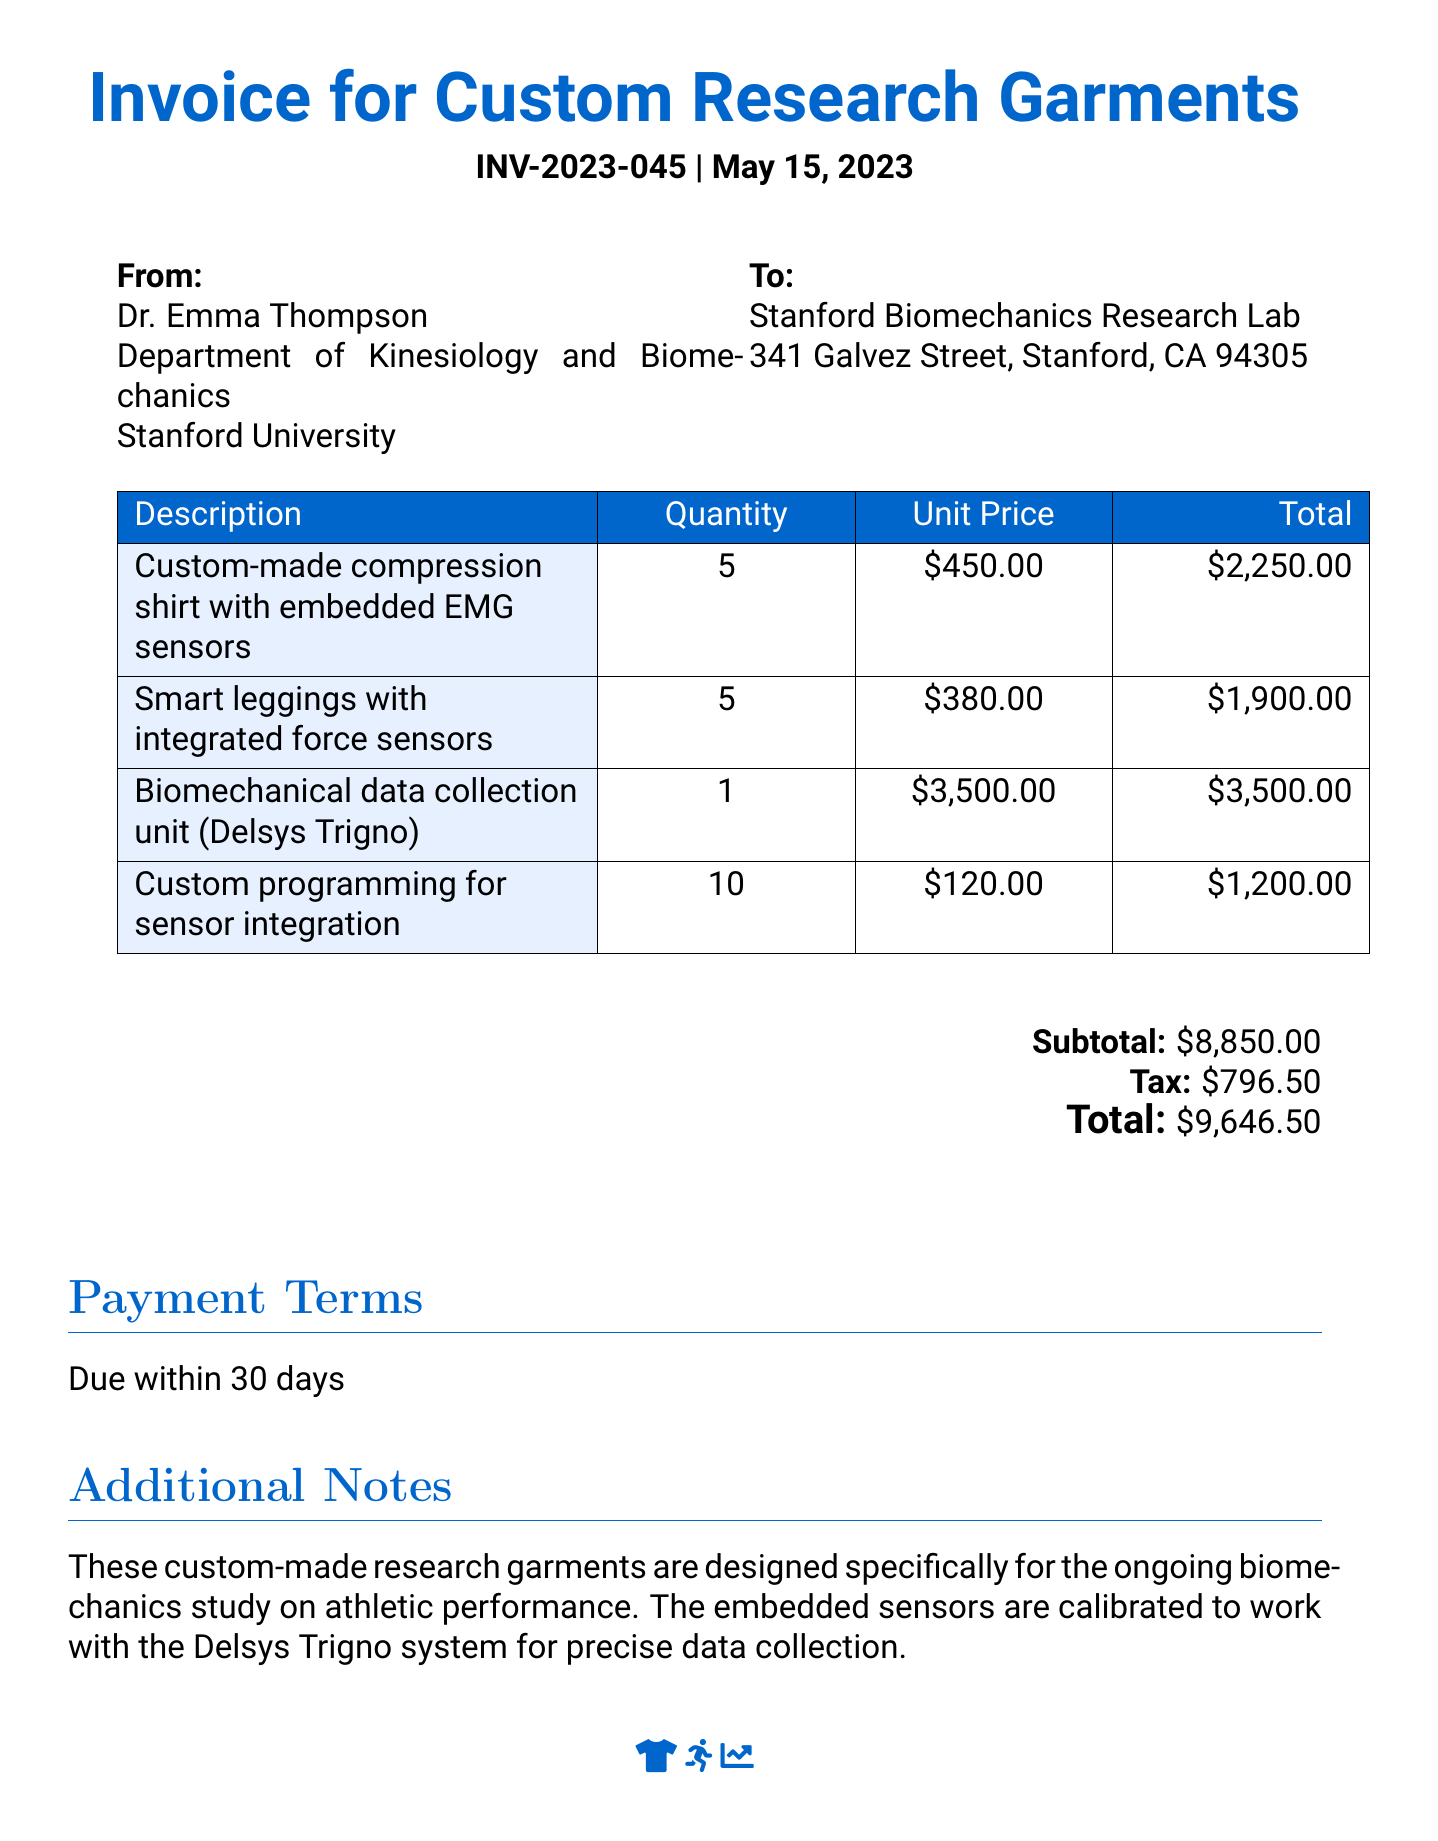What is the invoice number? The invoice number is listed at the top of the document as INV-2023-045.
Answer: INV-2023-045 Who is the invoice from? The invoice is issued from Dr. Emma Thompson at Stanford University.
Answer: Dr. Emma Thompson What is the total amount due? The total amount due is found at the bottom of the document as \$9,646.50.
Answer: \$9,646.50 How many smart leggings were ordered? The document specifies that 5 smart leggings were ordered.
Answer: 5 What is the unit price of the custom-made compression shirt? The unit price for the compression shirt is stated as \$450.00.
Answer: \$450.00 What is the subtotal before tax? The subtotal is given as \$8,850.00 before tax.
Answer: \$8,850.00 What is the tax amount? The tax amount is provided in the document as \$796.50.
Answer: \$796.50 How many custom programming hours were included? The document indicates that 10 hours of custom programming were included.
Answer: 10 What is the due date for payment? The payment terms specify that the amount is due within 30 days.
Answer: 30 days 